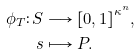Convert formula to latex. <formula><loc_0><loc_0><loc_500><loc_500>\phi _ { T } \colon S & \longrightarrow { [ 0 , 1 ] } ^ { \kappa ^ { n } } , \\ s & \longmapsto P .</formula> 